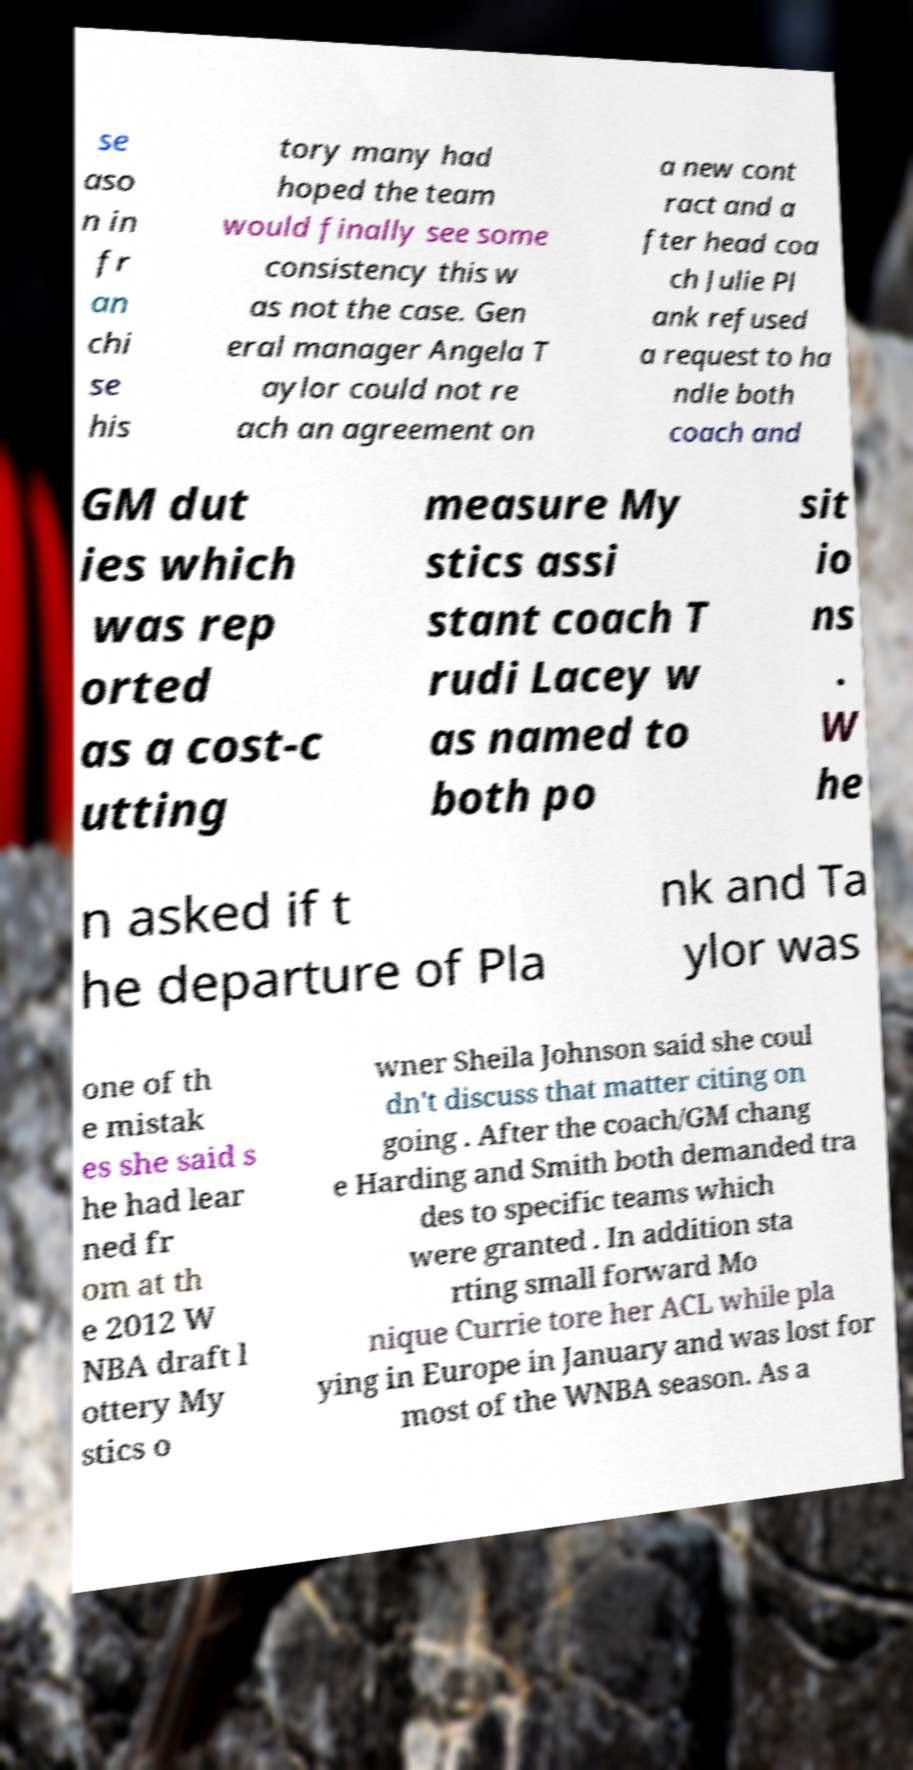There's text embedded in this image that I need extracted. Can you transcribe it verbatim? se aso n in fr an chi se his tory many had hoped the team would finally see some consistency this w as not the case. Gen eral manager Angela T aylor could not re ach an agreement on a new cont ract and a fter head coa ch Julie Pl ank refused a request to ha ndle both coach and GM dut ies which was rep orted as a cost-c utting measure My stics assi stant coach T rudi Lacey w as named to both po sit io ns . W he n asked if t he departure of Pla nk and Ta ylor was one of th e mistak es she said s he had lear ned fr om at th e 2012 W NBA draft l ottery My stics o wner Sheila Johnson said she coul dn't discuss that matter citing on going . After the coach/GM chang e Harding and Smith both demanded tra des to specific teams which were granted . In addition sta rting small forward Mo nique Currie tore her ACL while pla ying in Europe in January and was lost for most of the WNBA season. As a 